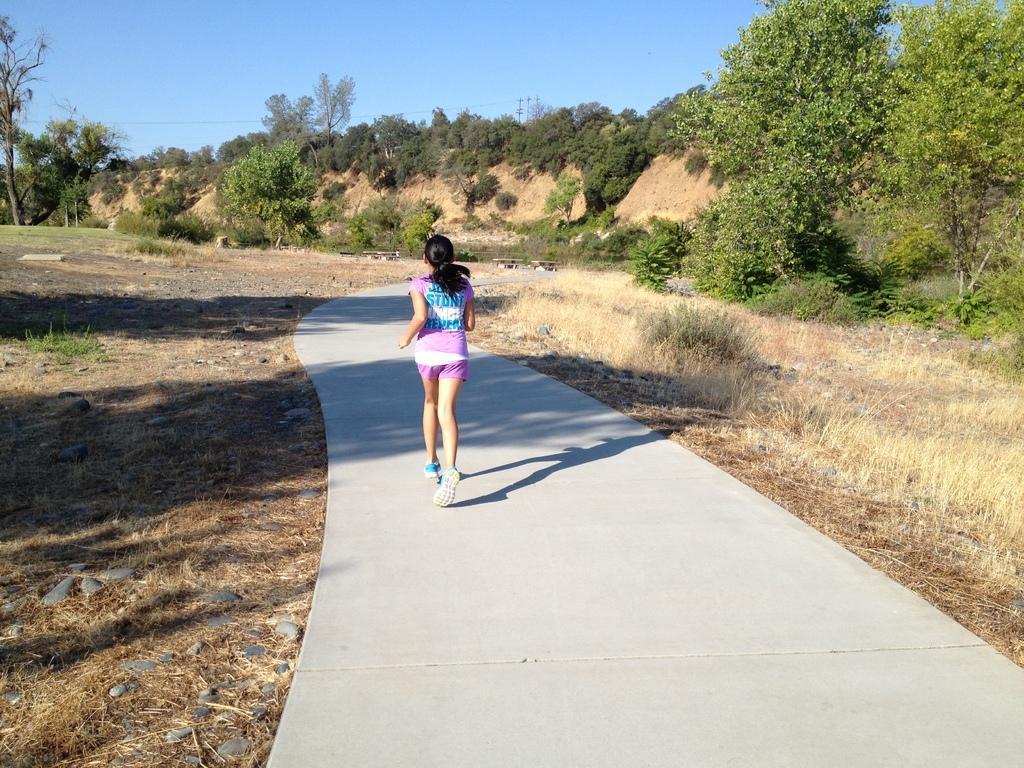Please provide a concise description of this image. In this image we can see a woman is running on the road. Here we can see ground, grass, plants, and trees. In the background there is sky. 